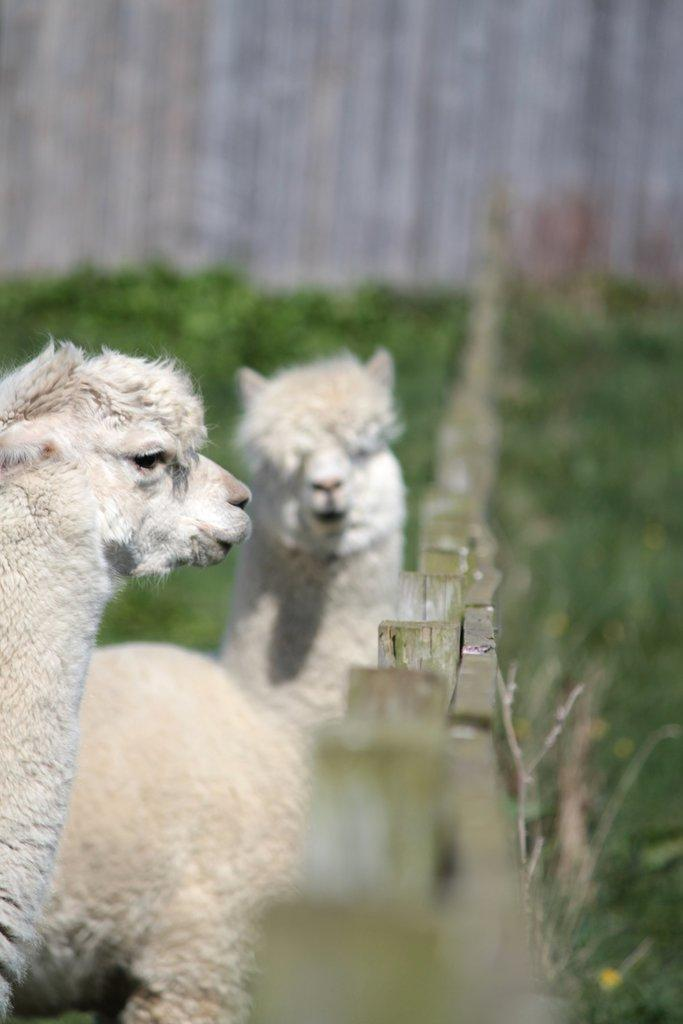What type of animals are in the image? There are sheep in the image. What color are the sheep? The sheep are white in color. Where are the sheep located in relation to the wooden fencing? The sheep are near a wooden fencing. What can be seen in the background of the image? There are plants in the background of the image. How is the background of the image depicted? The background of the image is blurred. What type of stomach ailment does the sister of the sheep have in the image? There is no mention of a sister or any stomach ailment in the image; it features white sheep near a wooden fencing with a blurred background. 